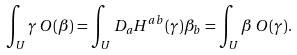<formula> <loc_0><loc_0><loc_500><loc_500>\int _ { U } \gamma \, O ( \beta ) = \int _ { U } D _ { a } H ^ { a b } ( \gamma ) \beta _ { b } = \int _ { U } \beta \, O ( \gamma ) .</formula> 